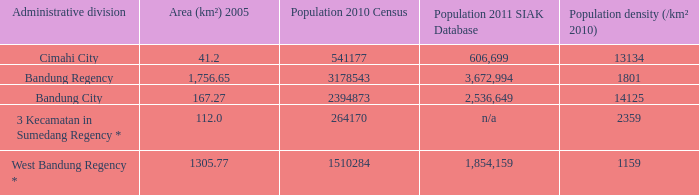What is the area of cimahi city? 41.2. 